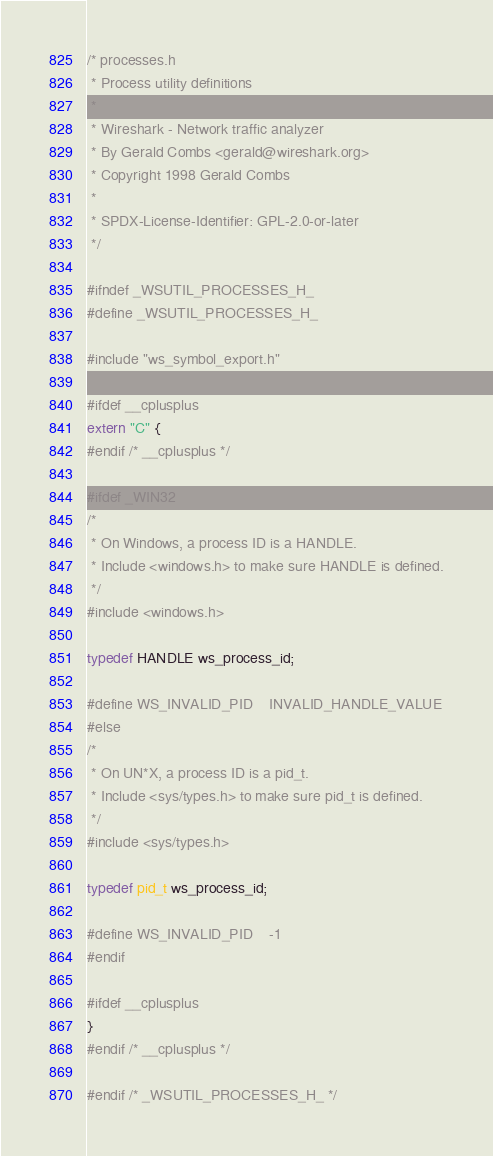<code> <loc_0><loc_0><loc_500><loc_500><_C_>/* processes.h
 * Process utility definitions
 *
 * Wireshark - Network traffic analyzer
 * By Gerald Combs <gerald@wireshark.org>
 * Copyright 1998 Gerald Combs
 *
 * SPDX-License-Identifier: GPL-2.0-or-later
 */

#ifndef _WSUTIL_PROCESSES_H_
#define _WSUTIL_PROCESSES_H_

#include "ws_symbol_export.h"

#ifdef __cplusplus
extern "C" {
#endif /* __cplusplus */

#ifdef _WIN32
/*
 * On Windows, a process ID is a HANDLE.
 * Include <windows.h> to make sure HANDLE is defined.
 */
#include <windows.h>

typedef HANDLE ws_process_id;

#define WS_INVALID_PID    INVALID_HANDLE_VALUE
#else
/*
 * On UN*X, a process ID is a pid_t.
 * Include <sys/types.h> to make sure pid_t is defined.
 */
#include <sys/types.h>

typedef pid_t ws_process_id;

#define WS_INVALID_PID    -1
#endif

#ifdef __cplusplus
}
#endif /* __cplusplus */

#endif /* _WSUTIL_PROCESSES_H_ */
</code> 